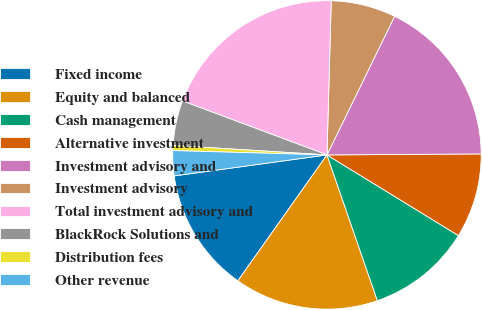Convert chart to OTSL. <chart><loc_0><loc_0><loc_500><loc_500><pie_chart><fcel>Fixed income<fcel>Equity and balanced<fcel>Cash management<fcel>Alternative investment<fcel>Investment advisory and<fcel>Investment advisory<fcel>Total investment advisory and<fcel>BlackRock Solutions and<fcel>Distribution fees<fcel>Other revenue<nl><fcel>13.02%<fcel>15.1%<fcel>10.94%<fcel>8.86%<fcel>17.67%<fcel>6.78%<fcel>19.75%<fcel>4.7%<fcel>0.54%<fcel>2.62%<nl></chart> 